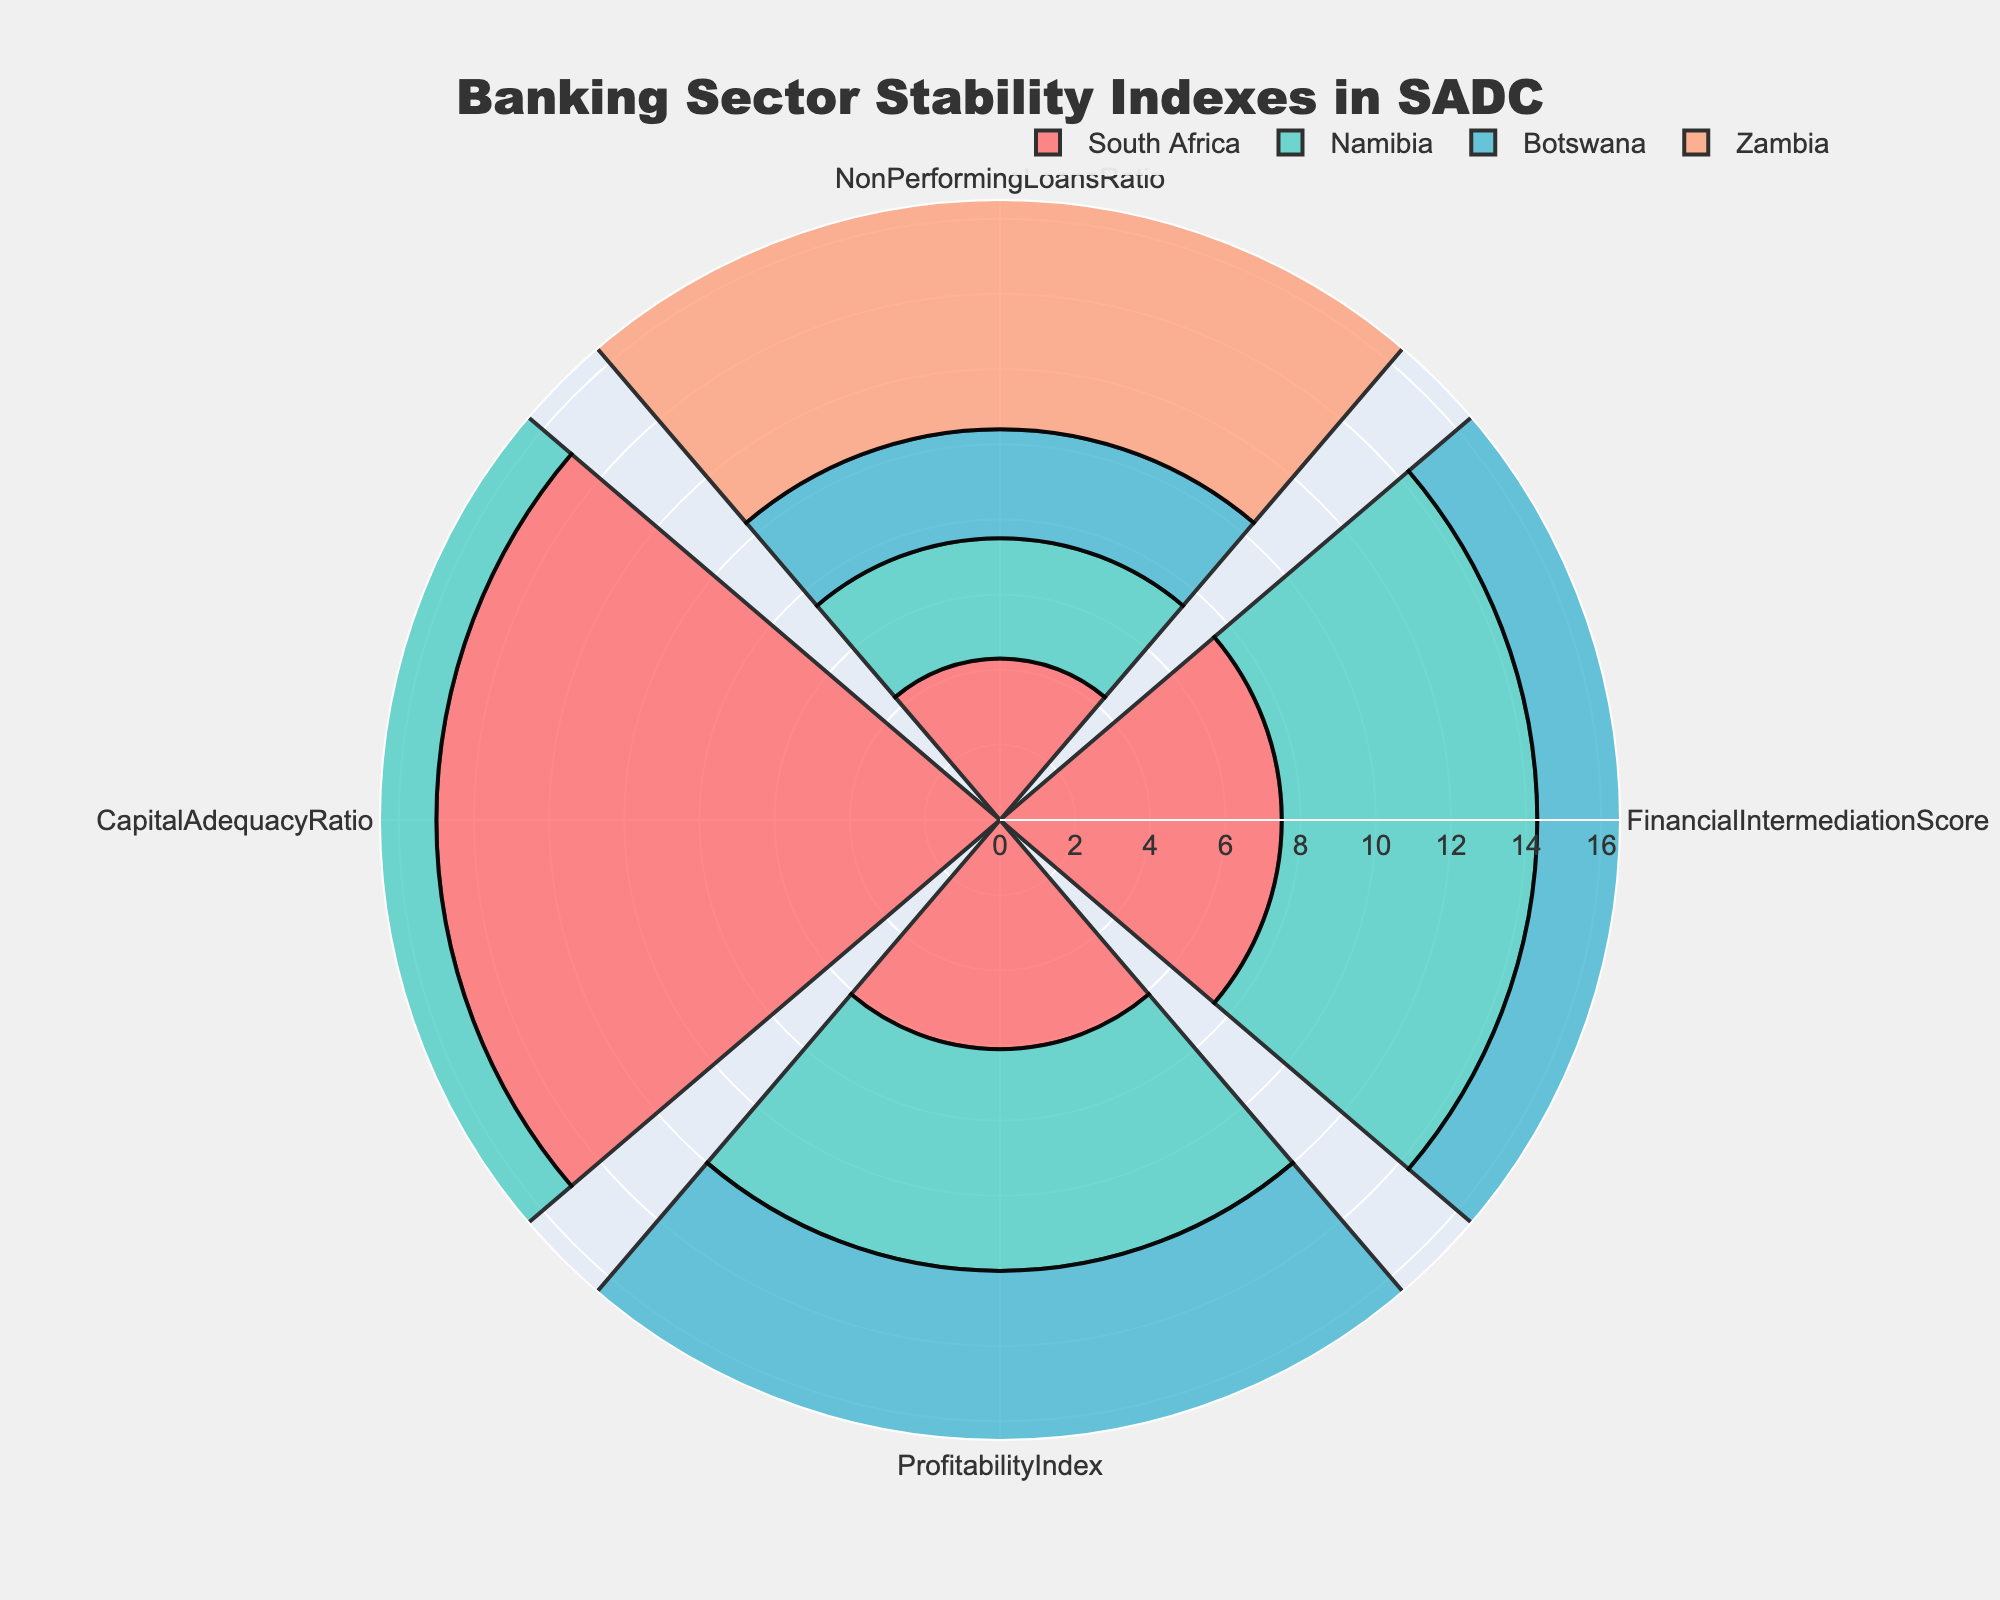Which country has the highest Financial Intermediation Score? Refer to the "FinancialIntermediationScore" section in the rose chart. The highest score is attributed to the country section that extends the furthest outward. South Africa’s segment is the longest in this category.
Answer: South Africa Which country has the lowest Profitability Index? Look at the "ProfitabilityIndex" section in the rose chart. The shortest segment in this part represents the country with the lowest value. For this section, Zambia's segment is the shortest.
Answer: Zambia Compare the Non-Performing Loans Ratio of Namibia and Zambia. Which country has a higher ratio? Find the "NonPerformingLoansRatio" section in the rose chart. Visualize the segments representing Namibia and Zambia, then compare their lengths. Zambia’s segment extends further outward than Namibia’s.
Answer: Zambia What is the average Capital Adequacy Ratio among South Africa, Namibia, and Botswana? Sum up the values of the Capital Adequacy Ratio for South Africa (15.0), Namibia (14.5), and Botswana (14.0). Then, divide the sum by the number of countries, which is three. Calculation: (15.0 + 14.5 + 14.0) / 3 = 14.5
Answer: 14.5 How does Botswana’s Financial Intermediation Score compare to Namibia’s? Find the "FinancialIntermediationScore" section for Botswana and Namibia and compare their segment lengths. Botswana’s segment is slightly longer than Namibia’s.
Answer: Botswana's score is higher What is the range of the Financial Intermediation Scores across all countries? Identify the highest and lowest scores in the "FinancialIntermediationScore" section from the rose chart. The highest score is South Africa’s 7.5, and the lowest is Zambia’s 6.5. The range is calculated by subtracting the lowest score from the highest: 7.5 - 6.5 = 1.0
Answer: 1.0 Which country shows the least stability in the banking sector based on the Non-Performing Loans Ratio? Refer to the "NonPerformingLoansRatio" section in the rose chart. The most extended segment in this category indicates the highest Non-Performing Loans Ratio, demonstrating the least stability. Zambia has the longest segment here.
Answer: Zambia Based on the rose chart, what can you infer about Zambia's Capital Adequacy Ratio compared to the other countries? Examine the "CapitalAdequacyRatio" section in the rose chart. Zambia's segment in this section is the shortest among the countries.
Answer: Zambia has the lowest Capital Adequacy Ratio 